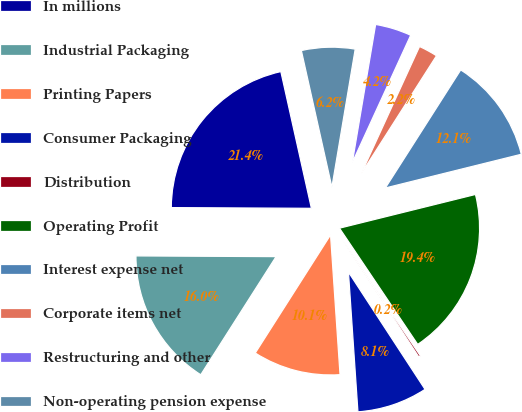Convert chart to OTSL. <chart><loc_0><loc_0><loc_500><loc_500><pie_chart><fcel>In millions<fcel>Industrial Packaging<fcel>Printing Papers<fcel>Consumer Packaging<fcel>Distribution<fcel>Operating Profit<fcel>Interest expense net<fcel>Corporate items net<fcel>Restructuring and other<fcel>Non-operating pension expense<nl><fcel>21.42%<fcel>16.05%<fcel>10.11%<fcel>8.13%<fcel>0.22%<fcel>19.44%<fcel>12.09%<fcel>2.2%<fcel>4.18%<fcel>6.16%<nl></chart> 